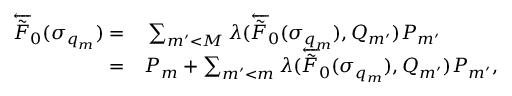Convert formula to latex. <formula><loc_0><loc_0><loc_500><loc_500>\begin{array} { r l } { \overleftarrow { \tilde { F } } _ { 0 } ( \sigma _ { q _ { m } } ) = } & \sum _ { m ^ { \prime } < M } \lambda ( \overleftarrow { \tilde { F } } _ { 0 } ( \sigma _ { q _ { m } } ) , Q _ { m ^ { \prime } } ) P _ { m ^ { \prime } } } \\ { = } & P _ { m } + \sum _ { m ^ { \prime } < m } \lambda ( \overleftarrow { \tilde { F } } _ { 0 } ( \sigma _ { q _ { m } } ) , Q _ { m ^ { \prime } } ) P _ { m ^ { \prime } } , } \end{array}</formula> 